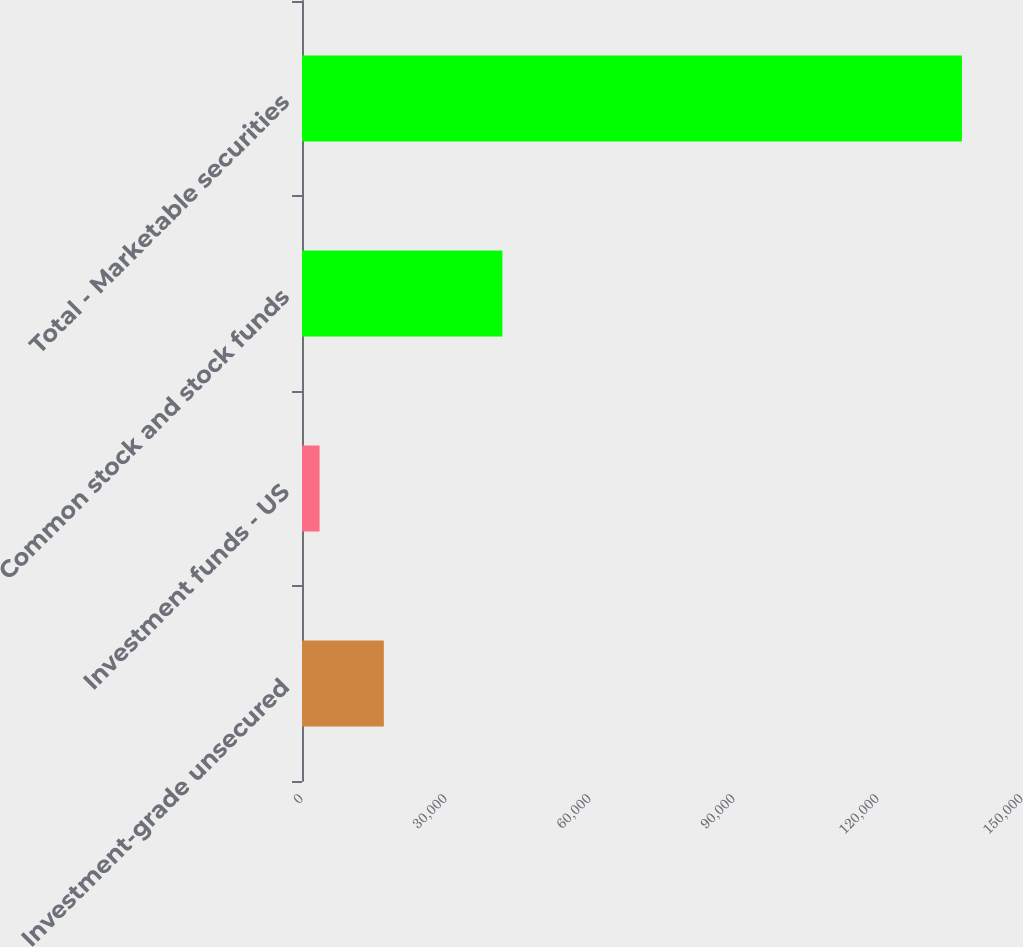Convert chart. <chart><loc_0><loc_0><loc_500><loc_500><bar_chart><fcel>Investment-grade unsecured<fcel>Investment funds - US<fcel>Common stock and stock funds<fcel>Total - Marketable securities<nl><fcel>17047.9<fcel>3666<fcel>41746<fcel>137485<nl></chart> 